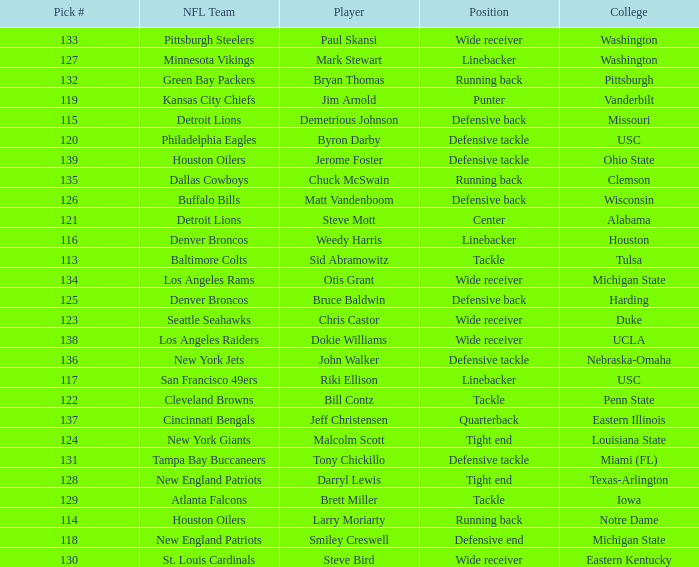How many players did the philadelphia eagles pick? 1.0. 